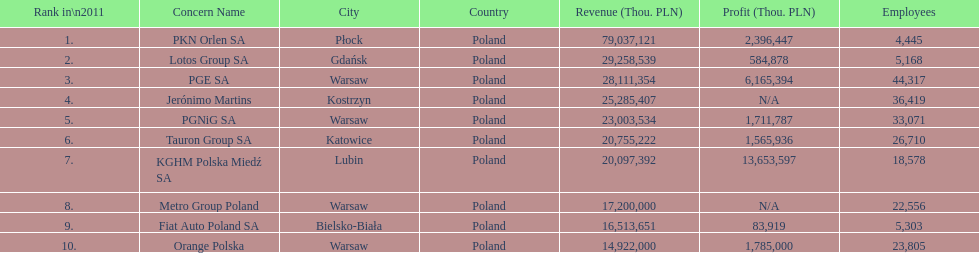What is the difference in employees for rank 1 and rank 3? 39,872 employees. 